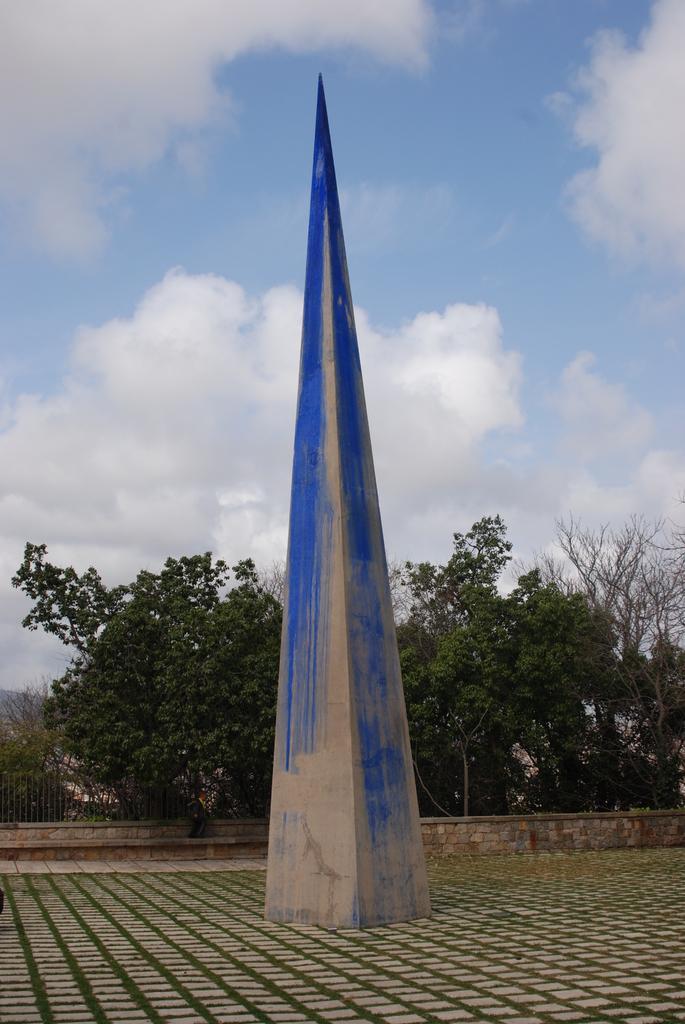Can you describe this image briefly? Here we can see pyramid on surface. Background we can see trees,fence and sky with clouds. 